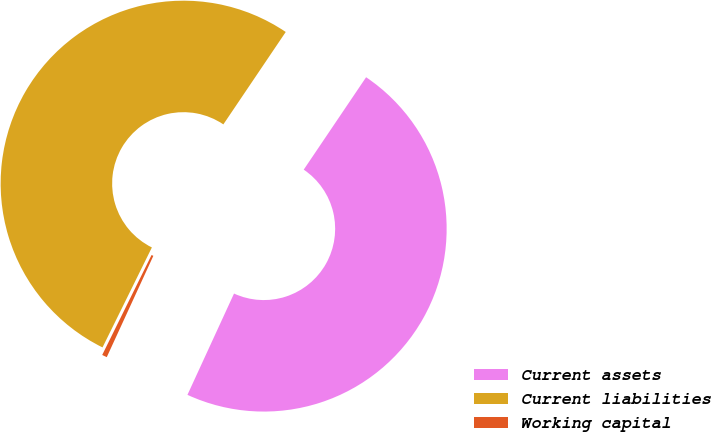Convert chart to OTSL. <chart><loc_0><loc_0><loc_500><loc_500><pie_chart><fcel>Current assets<fcel>Current liabilities<fcel>Working capital<nl><fcel>47.41%<fcel>52.15%<fcel>0.44%<nl></chart> 